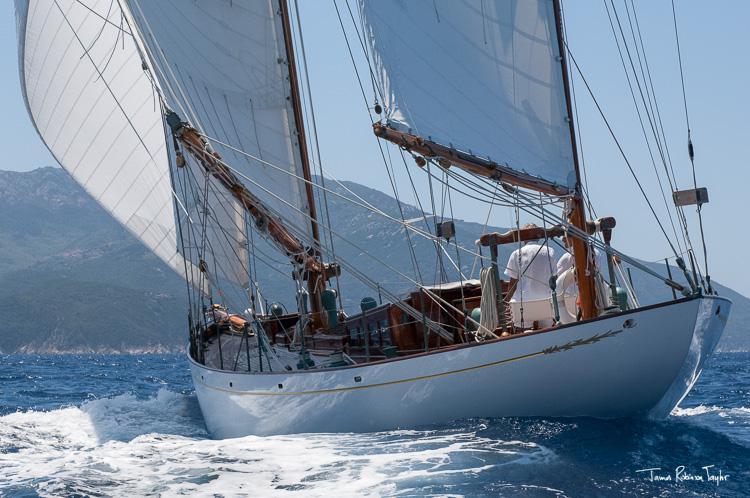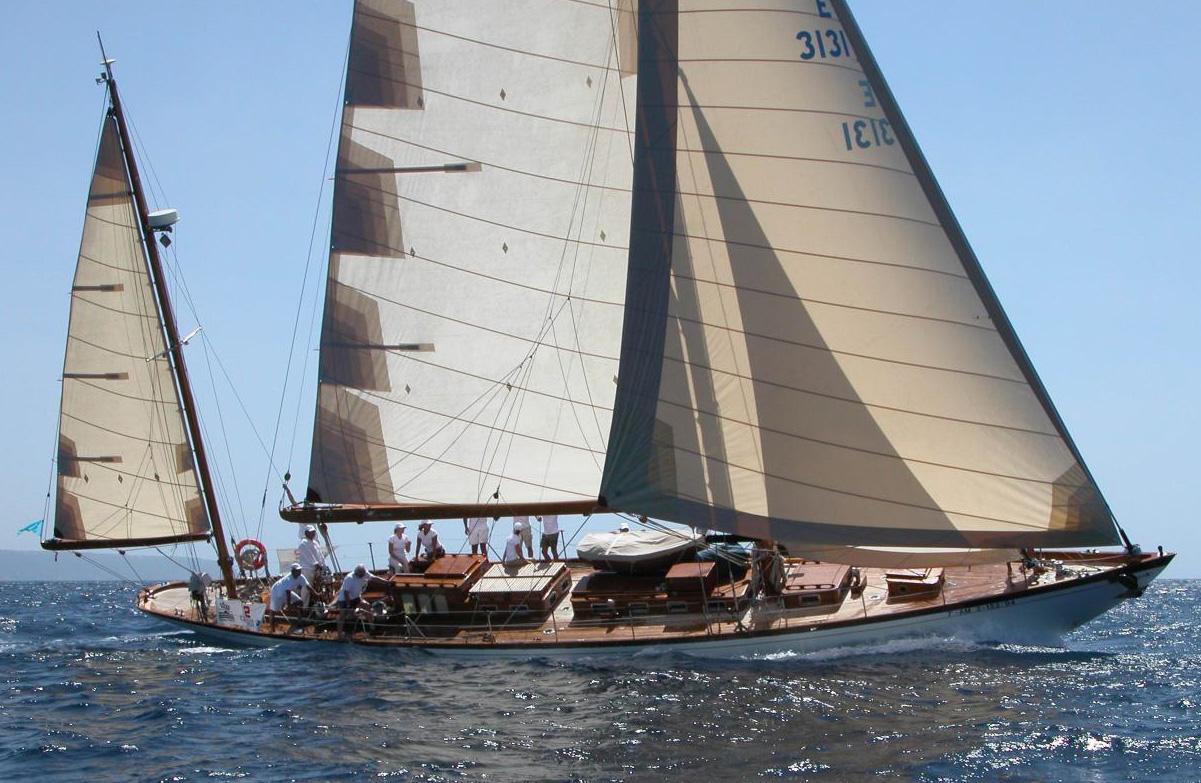The first image is the image on the left, the second image is the image on the right. Considering the images on both sides, is "There are exactly two sailboats on the water." valid? Answer yes or no. Yes. The first image is the image on the left, the second image is the image on the right. Considering the images on both sides, is "There are at least three sailboats on the water." valid? Answer yes or no. No. 